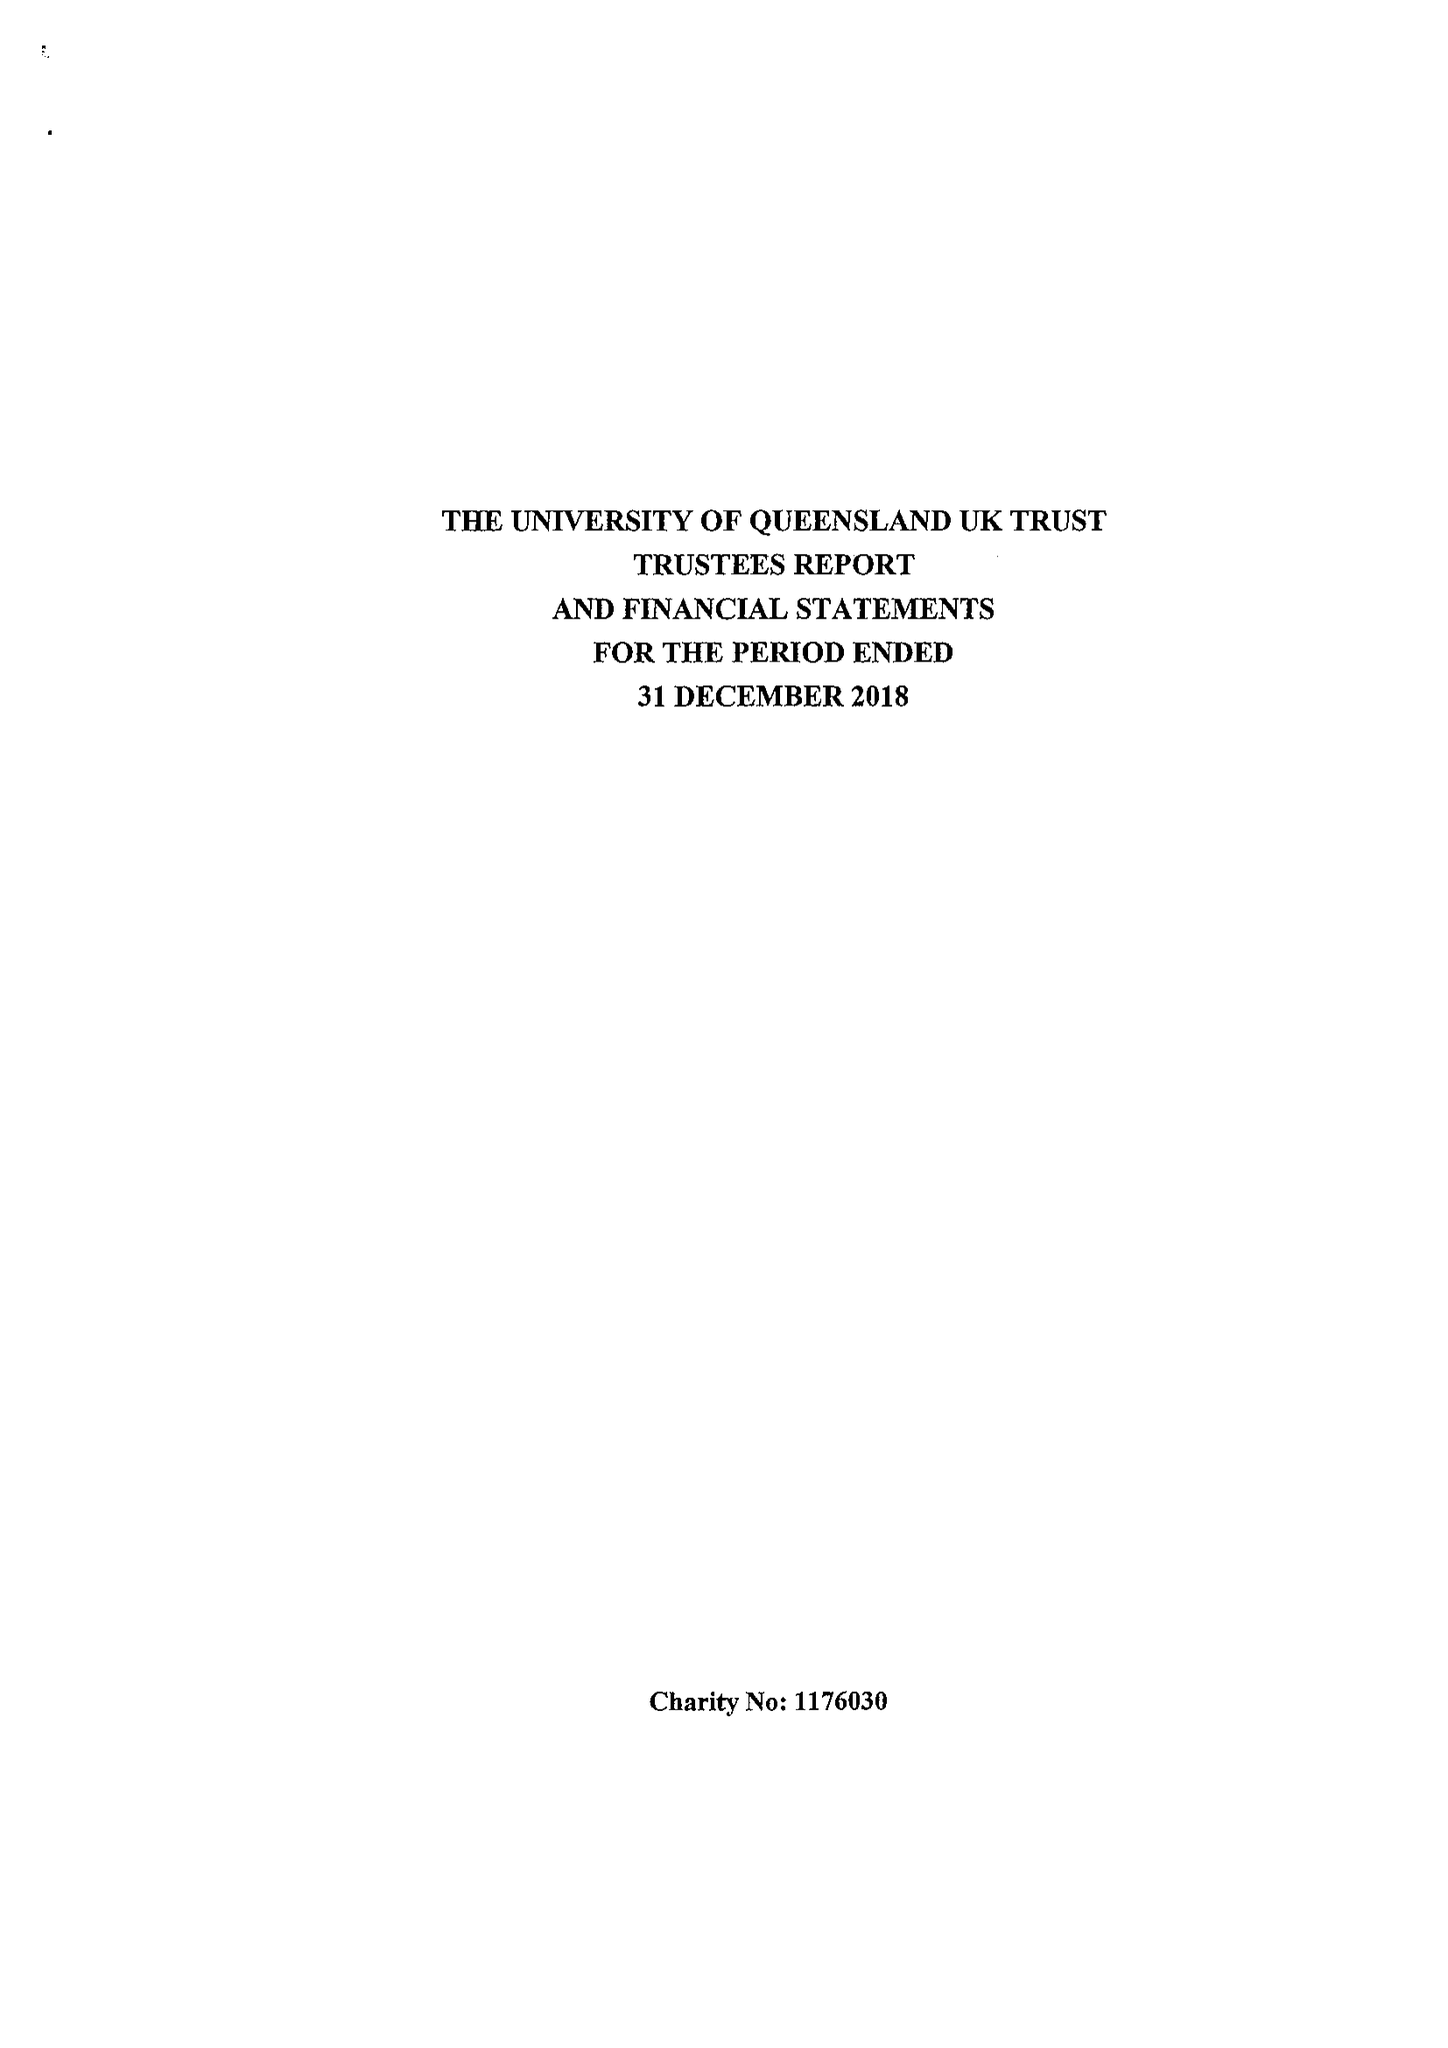What is the value for the charity_name?
Answer the question using a single word or phrase. The University Of Queensland Uk Trust 